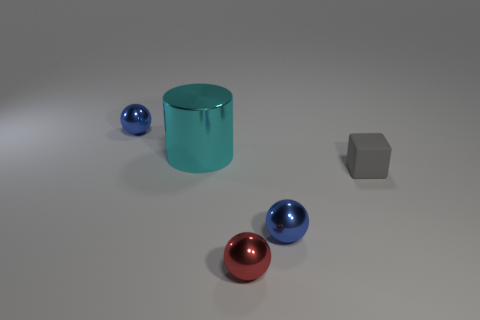Add 1 cyan objects. How many objects exist? 6 Subtract all cubes. How many objects are left? 4 Subtract all blue metallic balls. Subtract all tiny red things. How many objects are left? 2 Add 5 tiny metallic spheres. How many tiny metallic spheres are left? 8 Add 1 cyan cylinders. How many cyan cylinders exist? 2 Subtract 0 cyan balls. How many objects are left? 5 